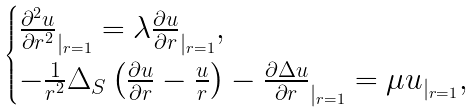Convert formula to latex. <formula><loc_0><loc_0><loc_500><loc_500>\begin{cases} \frac { \partial ^ { 2 } u } { \partial r ^ { 2 } } _ { | _ { r = 1 } } = \lambda \frac { \partial u } { \partial r } _ { | _ { r = 1 } } , \\ - \frac { 1 } { r ^ { 2 } } { \Delta _ { S } } \left ( \frac { \partial u } { \partial r } - \frac { u } { r } \right ) - \frac { \partial \Delta u } { \partial r } _ { | _ { r = 1 } } = \mu u _ { | _ { r = 1 } } , \end{cases}</formula> 